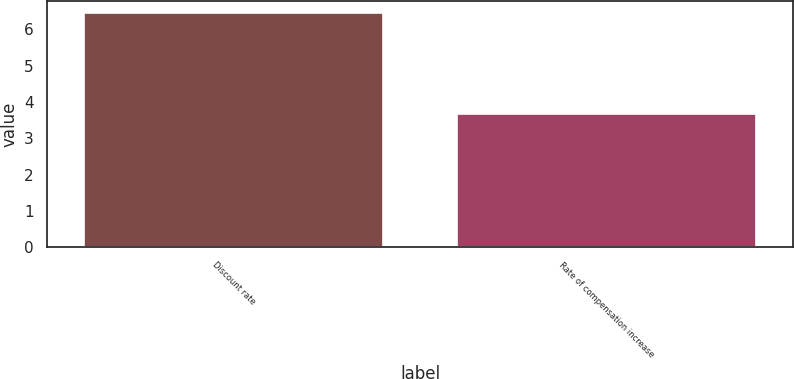Convert chart. <chart><loc_0><loc_0><loc_500><loc_500><bar_chart><fcel>Discount rate<fcel>Rate of compensation increase<nl><fcel>6.46<fcel>3.67<nl></chart> 